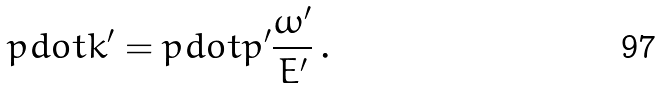<formula> <loc_0><loc_0><loc_500><loc_500>p d o t k ^ { \prime } = p d o t p ^ { \prime } \frac { \omega ^ { \prime } } { E ^ { \prime } } \, .</formula> 